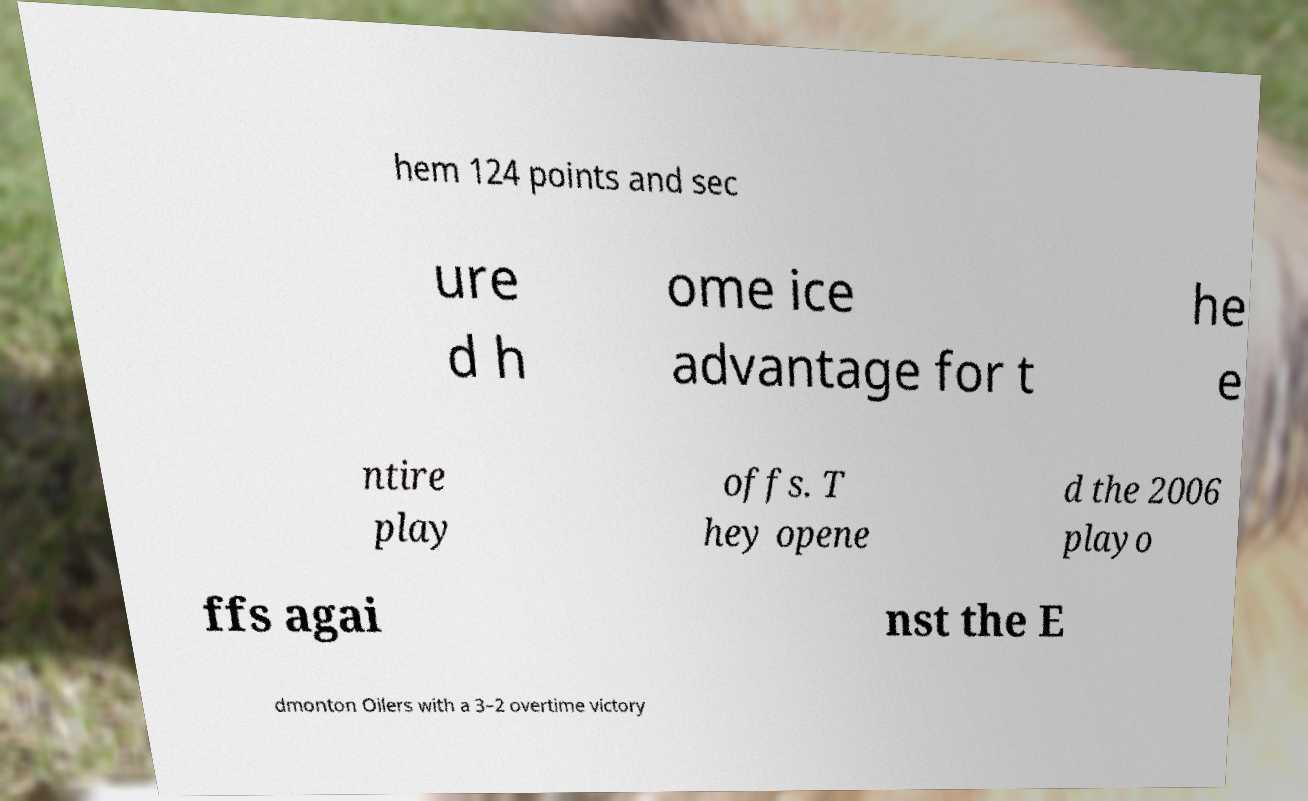What messages or text are displayed in this image? I need them in a readable, typed format. hem 124 points and sec ure d h ome ice advantage for t he e ntire play offs. T hey opene d the 2006 playo ffs agai nst the E dmonton Oilers with a 3–2 overtime victory 